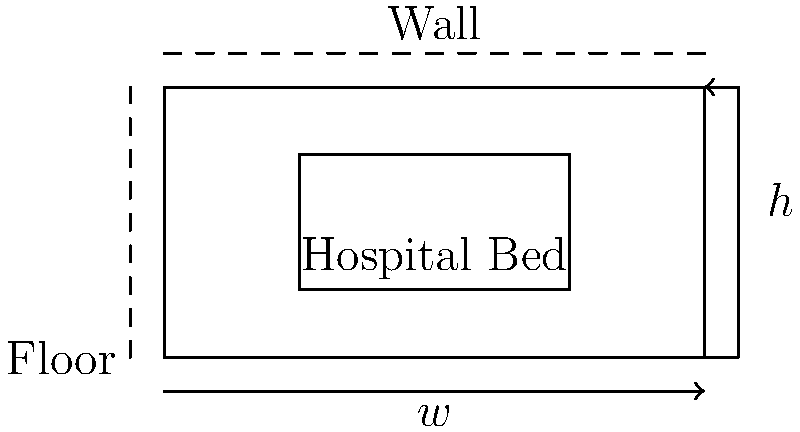In designing an ergonomic hospital room, you need to determine the optimal dimensions for a patient bed. Given that the room has a width of 8 feet and the bed should allow for 2 feet of clearance on each side for staff movement, what is the maximum width (w) of the bed that would still maintain proper ergonomic standards? Additionally, if the bed height (h) needs to be adjustable between 18 inches and 30 inches for patient comfort and staff efficiency, what is the total range of height adjustment? To solve this problem, let's break it down into steps:

1. Determining the maximum bed width (w):
   - Room width = 8 feet
   - Required clearance on each side = 2 feet
   - Total clearance needed = 2 feet × 2 sides = 4 feet
   - Maximum bed width = Room width - Total clearance
   - Maximum bed width = 8 feet - 4 feet = 4 feet

2. Calculating the range of height adjustment (h):
   - Minimum height = 18 inches
   - Maximum height = 30 inches
   - Range of height adjustment = Maximum height - Minimum height
   - Range of height adjustment = 30 inches - 18 inches = 12 inches

Therefore, the maximum width of the bed that maintains proper ergonomic standards is 4 feet, and the total range of height adjustment is 12 inches.

This design ensures that staff have enough space to move around the bed efficiently, improving their working conditions and reducing the risk of work-related injuries. The adjustable height range allows for patient comfort in various positions and enables staff to work at ergonomically appropriate heights, reducing strain during patient care activities.
Answer: Maximum bed width: 4 feet; Height adjustment range: 12 inches 